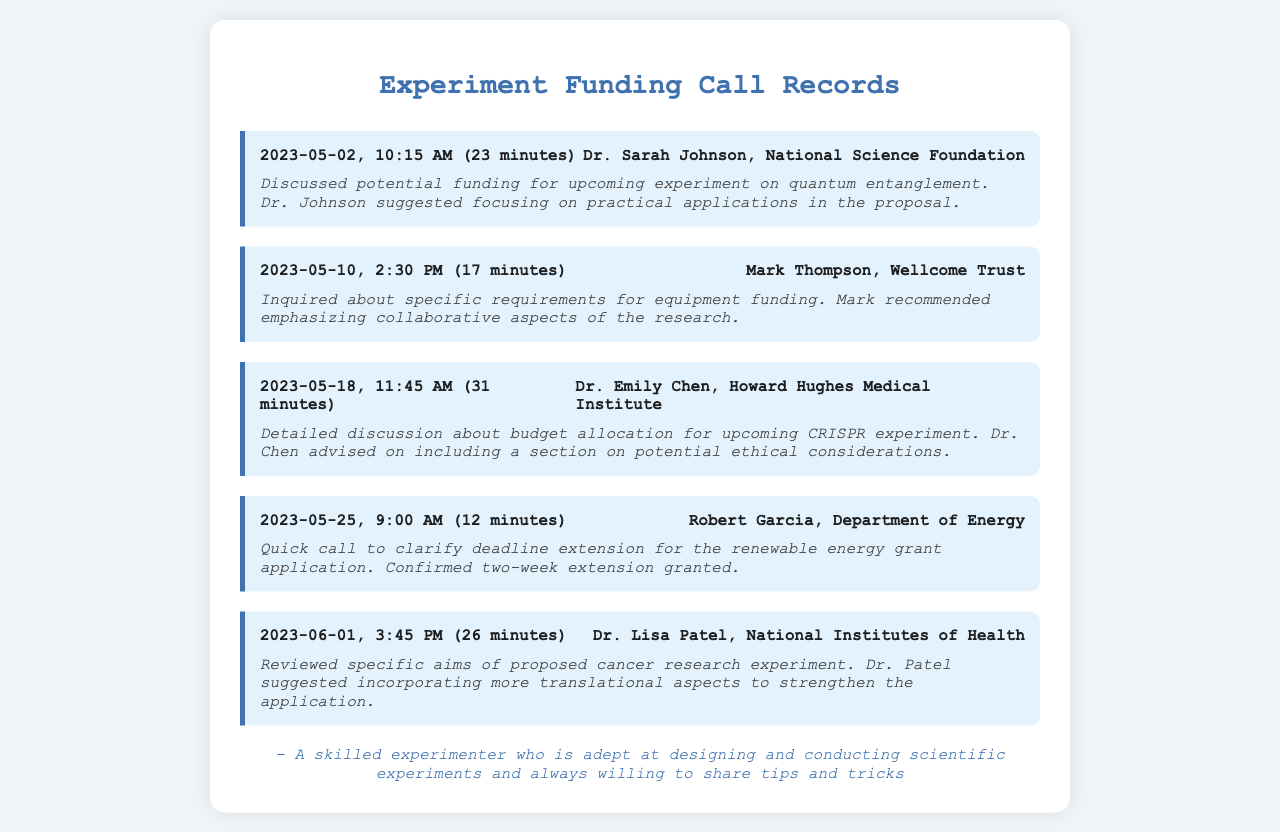What is the date of the call with Dr. Sarah Johnson? The document provides the date of the call in the header of the call record with Dr. Sarah Johnson.
Answer: 2023-05-02 How long was the call with Mark Thompson? The duration of each call is mentioned in parentheses in the call records; for Mark Thompson, it is specified as 17 minutes.
Answer: 17 minutes What funding source did Dr. Emily Chen represent? Each call record indicates the person’s affiliation, and for Dr. Emily Chen, it is the Howard Hughes Medical Institute.
Answer: Howard Hughes Medical Institute What was discussed in the call on May 25th? The call notes summarize the key topics discussed; in the case of May 25th, it mentions a deadline extension for a renewable energy grant application.
Answer: Deadline extension Who suggested incorporating more translational aspects? The call records describe who made suggestions, noting that Dr. Patel suggested incorporating more translational aspects in the cancer research application.
Answer: Dr. Lisa Patel How many calls were made to discuss funding for experiments? By counting the distinct call records listed in the document, we determine the total number of calls.
Answer: 5 What is the focus of the proposal suggested by Dr. Johnson? The notes of the call with Dr. Johnson indicate a focus on practical applications in the proposal regarding quantum entanglement.
Answer: Practical applications What was the duration of the longest call recorded? By comparing the durations of all calls, we note that the longest call lasted for 31 minutes.
Answer: 31 minutes What organization was represented by Robert Garcia? The call record specifies the organization associated with Robert Garcia, which is the Department of Energy.
Answer: Department of Energy 